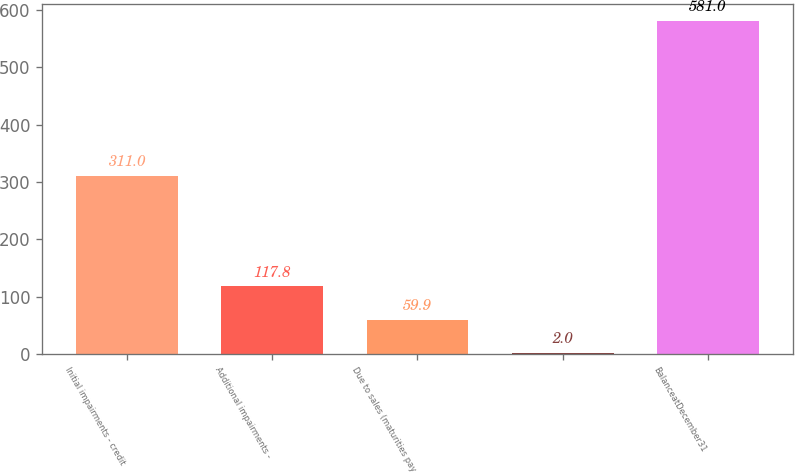Convert chart to OTSL. <chart><loc_0><loc_0><loc_500><loc_500><bar_chart><fcel>Initial impairments - credit<fcel>Additional impairments -<fcel>Due to sales (maturities pay<fcel>Unnamed: 3<fcel>BalanceatDecember31<nl><fcel>311<fcel>117.8<fcel>59.9<fcel>2<fcel>581<nl></chart> 